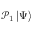Convert formula to latex. <formula><loc_0><loc_0><loc_500><loc_500>\mathcal { P } _ { 1 } \left | \Psi \right \rangle</formula> 